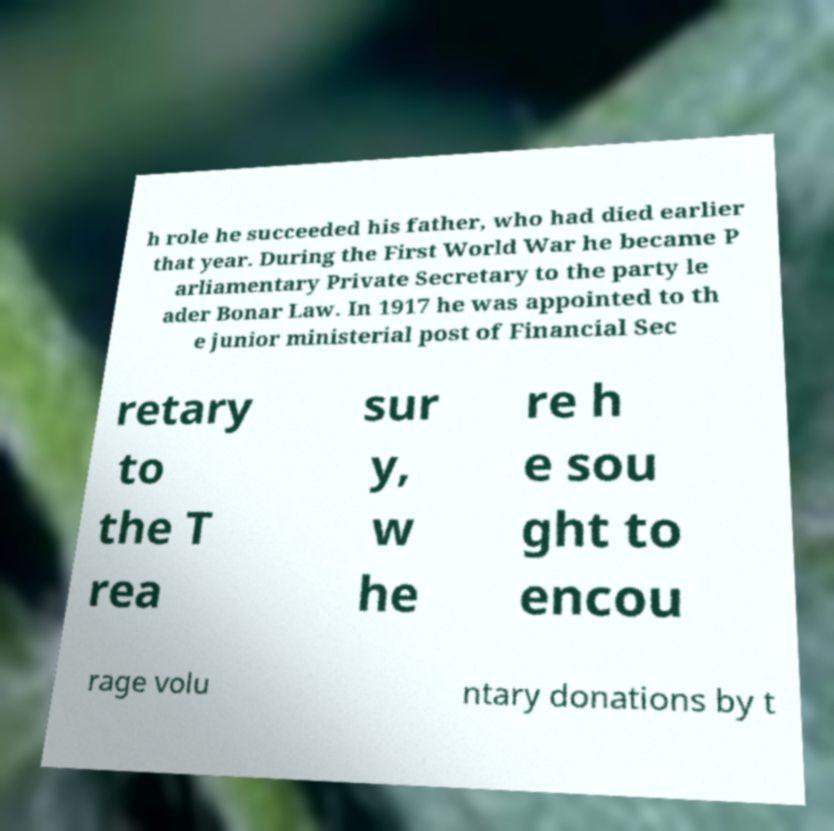Can you accurately transcribe the text from the provided image for me? h role he succeeded his father, who had died earlier that year. During the First World War he became P arliamentary Private Secretary to the party le ader Bonar Law. In 1917 he was appointed to th e junior ministerial post of Financial Sec retary to the T rea sur y, w he re h e sou ght to encou rage volu ntary donations by t 